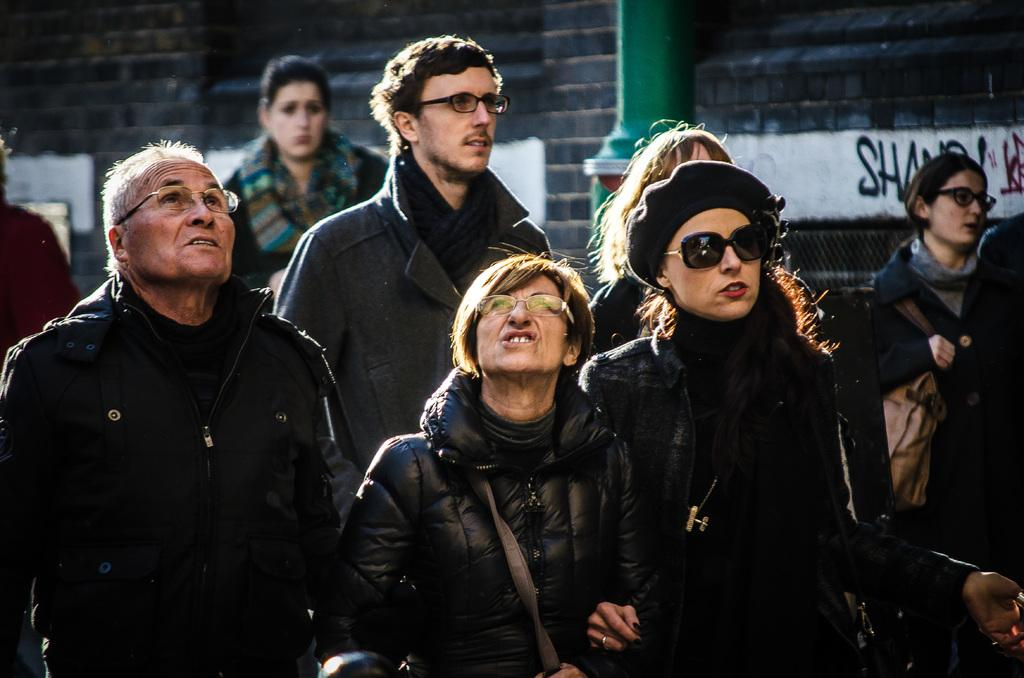How many people are in the image? There is a group of people standing in the image. What can be seen in the background of the image? There is a building in the background of the image. What is written or displayed on the building? There is text on the building. What type of object is attached to the wall in the image? There is a pipe on the wall in the image. What type of wine is being served in the image? There is no wine present in the image. What color is the ink used for the text on the building? The color of the ink cannot be determined from the image, as it only shows the text on the building, not the ink itself. 